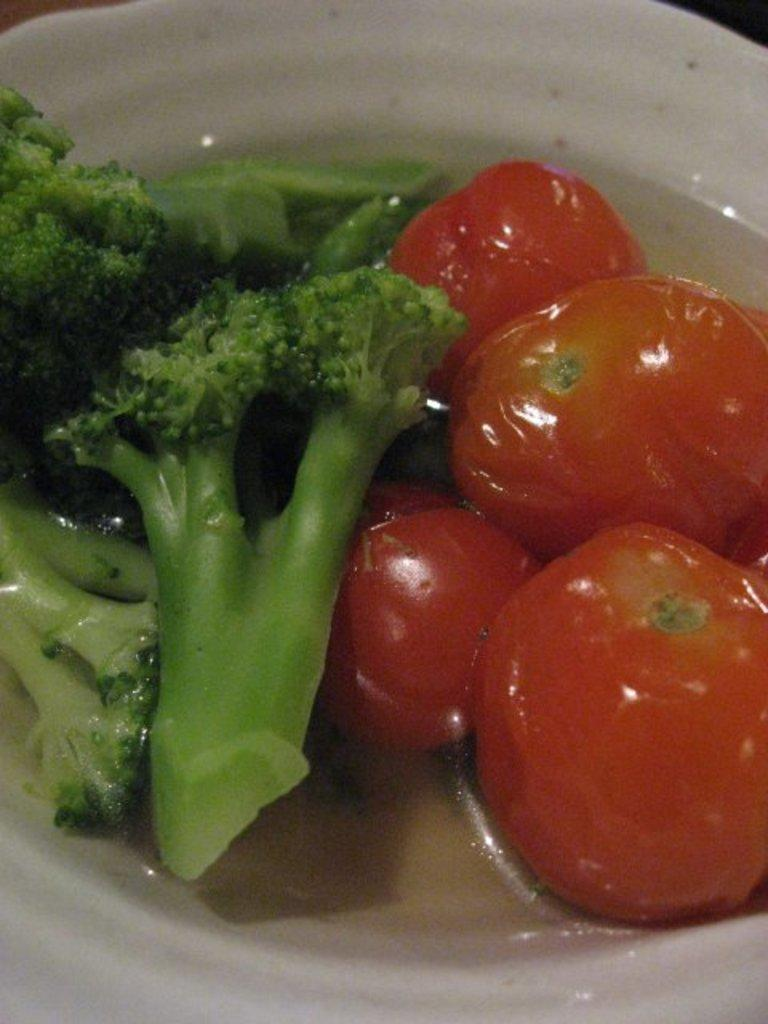What type of food can be seen on the plate in the image? There are tomatoes and broccoli pieces on the plate. What color is the plate? The plate is white. What type of key is used to unlock the tomatoes in the image? There are no keys present in the image, and tomatoes do not require keys to be unlocked. 